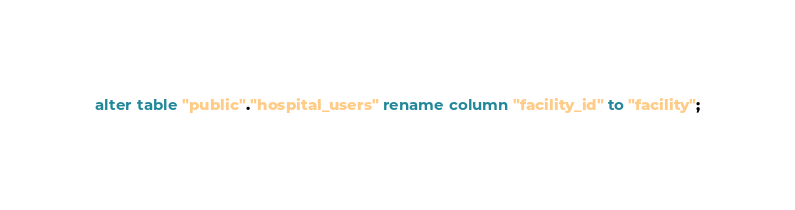Convert code to text. <code><loc_0><loc_0><loc_500><loc_500><_SQL_>alter table "public"."hospital_users" rename column "facility_id" to "facility";
</code> 